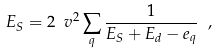Convert formula to latex. <formula><loc_0><loc_0><loc_500><loc_500>E _ { S } = 2 \ v ^ { 2 } \sum _ { q } \frac { 1 } { E _ { S } + E _ { d } - e _ { q } } \ ,</formula> 